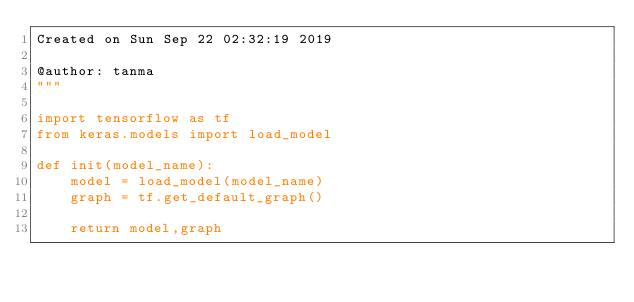Convert code to text. <code><loc_0><loc_0><loc_500><loc_500><_Python_>Created on Sun Sep 22 02:32:19 2019

@author: tanma
"""

import tensorflow as tf
from keras.models import load_model   

def init(model_name):
    model = load_model(model_name)
    graph = tf.get_default_graph()
    
    return model,graph</code> 